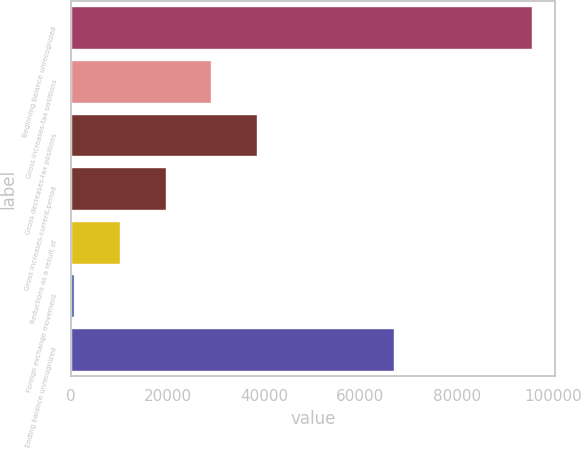Convert chart to OTSL. <chart><loc_0><loc_0><loc_500><loc_500><bar_chart><fcel>Beginning balance unrecognized<fcel>Gross increases-tax positions<fcel>Gross decreases-tax positions<fcel>Gross increases-current-period<fcel>Reductions as a result of<fcel>Foreign exchange movement<fcel>Ending balance unrecognized<nl><fcel>95664<fcel>29082.8<fcel>38594.4<fcel>19571.2<fcel>10059.6<fcel>548<fcel>66984<nl></chart> 